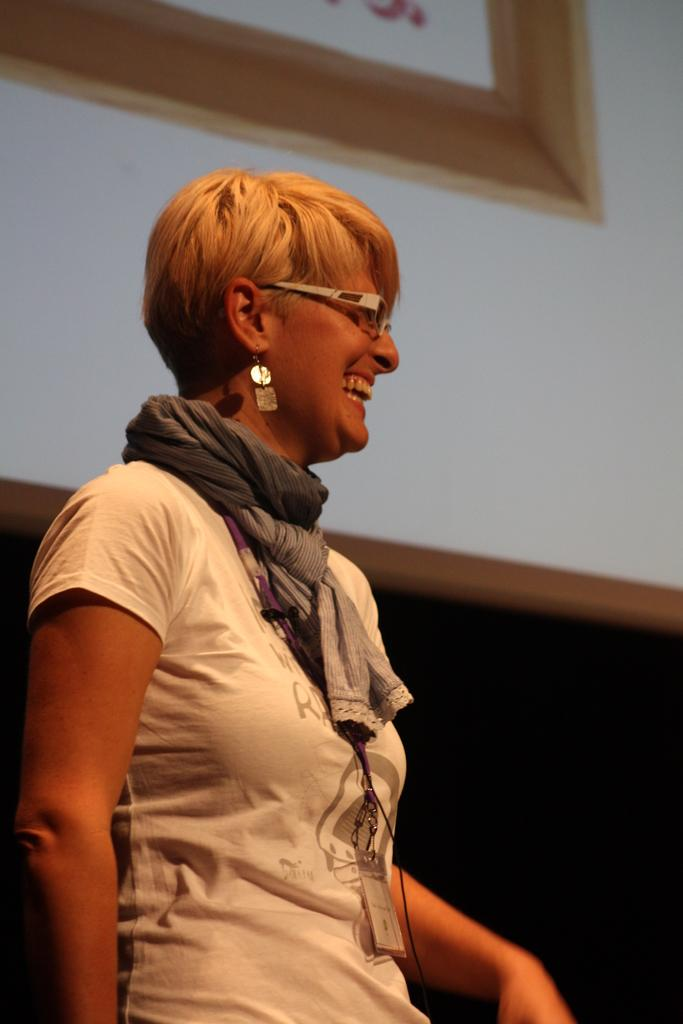Who is the main subject in the image? There is a lady in the image. What accessories is the lady wearing? The lady is wearing specs, a scarf, and earrings. Does the lady have any identification in the image? Yes, the lady has a tag. What can be seen in the background of the image? There is a wall with a photo frame in the background of the image. What type of iron can be seen in the lady's hand in the image? There is no iron present in the image; the lady is not holding any iron. What drink is the lady holding in the image? There is no drink visible in the image; the lady is not holding any drink. 